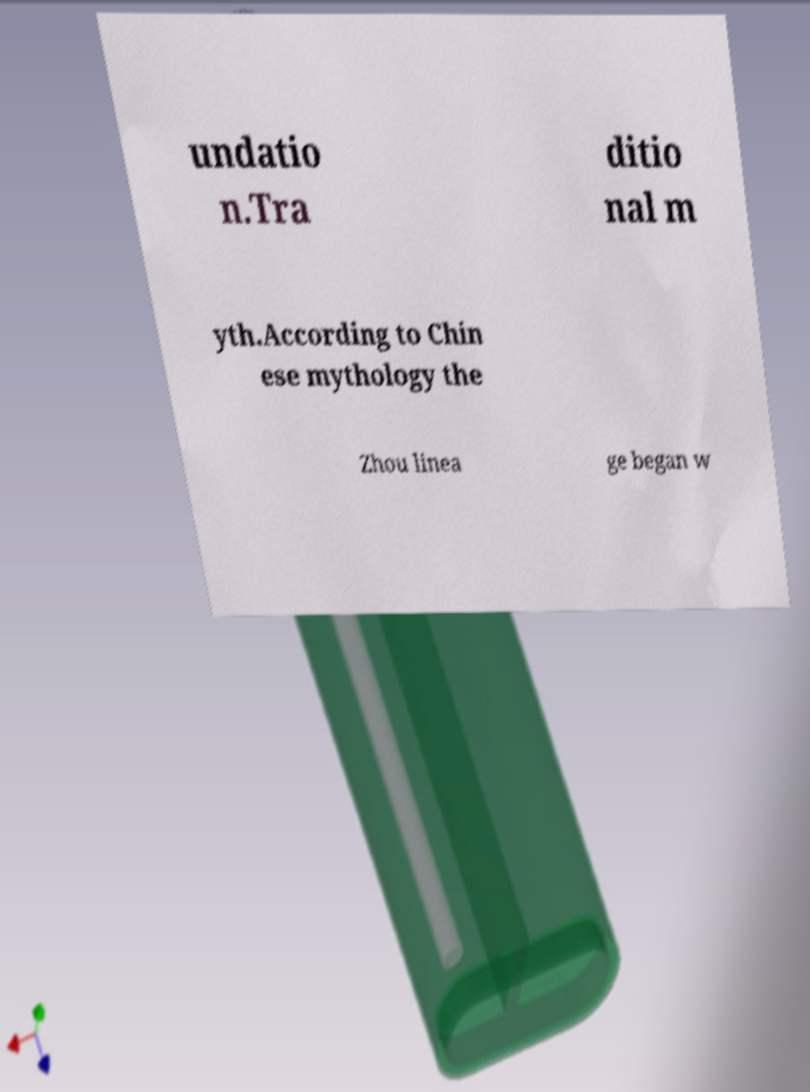What messages or text are displayed in this image? I need them in a readable, typed format. undatio n.Tra ditio nal m yth.According to Chin ese mythology the Zhou linea ge began w 